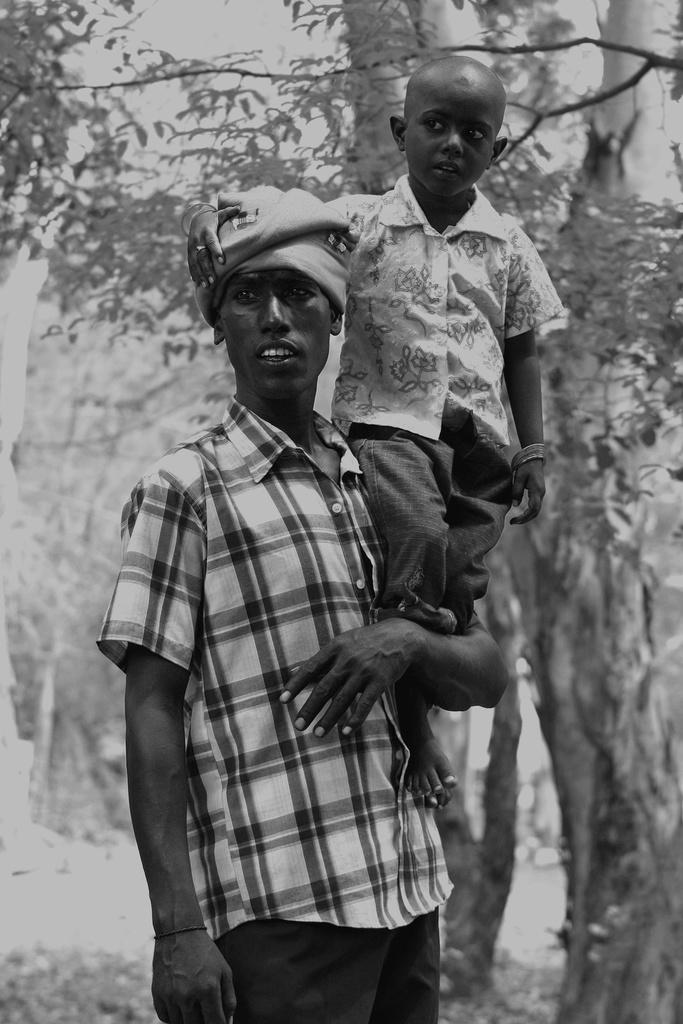What is the main subject of the image? There is a man standing in the image. What is the kid doing in the image? A kid is standing on the hand of the man. What can be seen in the background of the image? There are trees visible in the background of the image. What type of list is the man holding in the image? There is no list present in the image; the man is simply standing with a kid on his hand. 